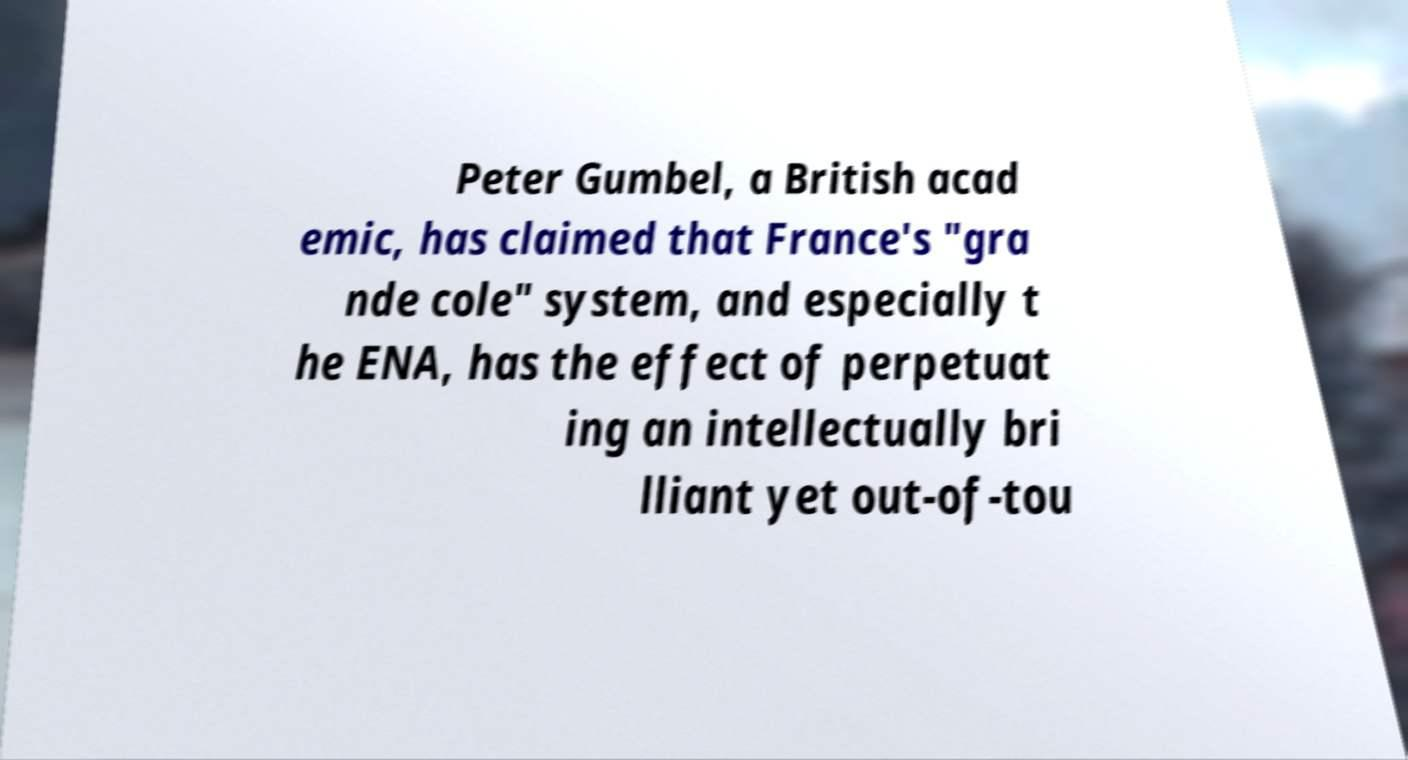I need the written content from this picture converted into text. Can you do that? Peter Gumbel, a British acad emic, has claimed that France's "gra nde cole" system, and especially t he ENA, has the effect of perpetuat ing an intellectually bri lliant yet out-of-tou 